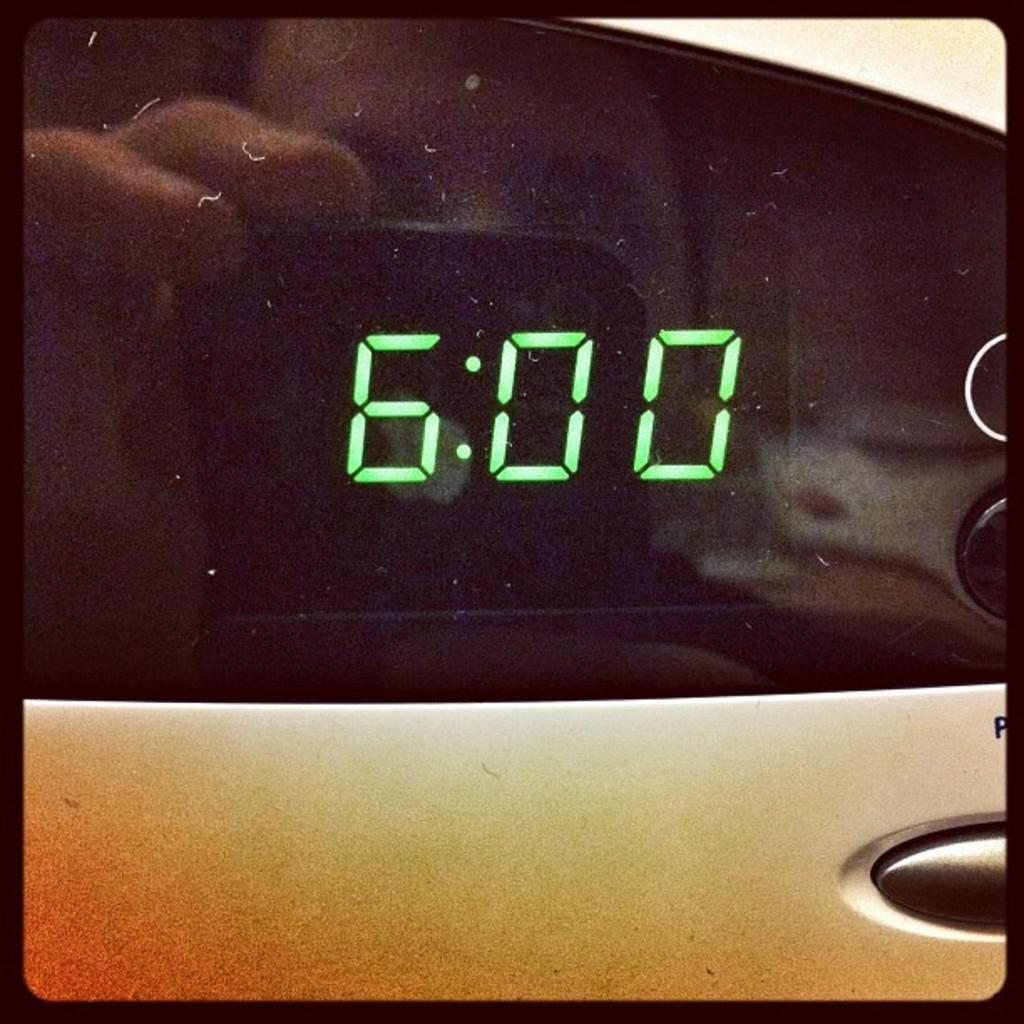<image>
Relay a brief, clear account of the picture shown. A clock with a reading of 6 o'clock, the clock is black and the letters are green. 